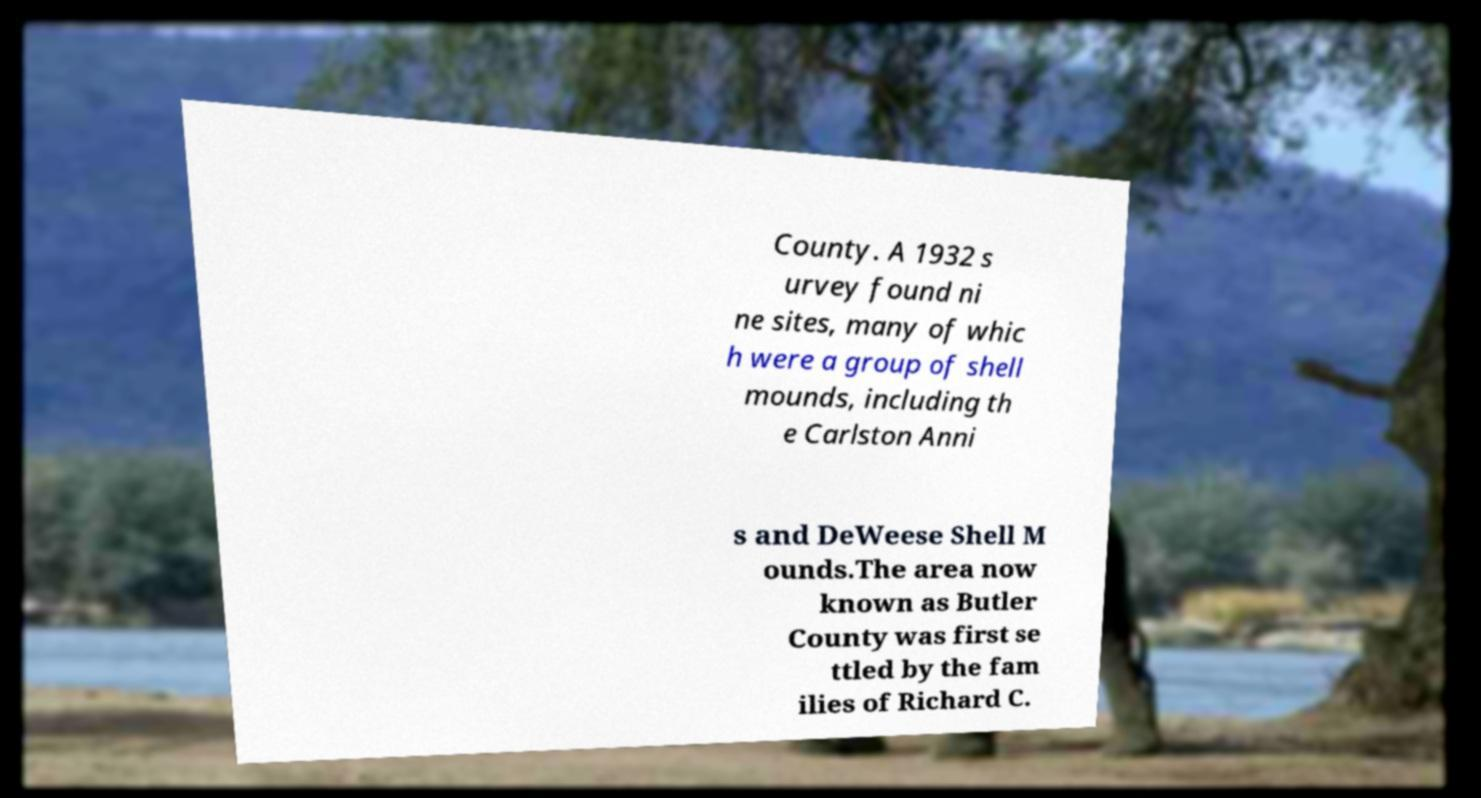Could you extract and type out the text from this image? County. A 1932 s urvey found ni ne sites, many of whic h were a group of shell mounds, including th e Carlston Anni s and DeWeese Shell M ounds.The area now known as Butler County was first se ttled by the fam ilies of Richard C. 